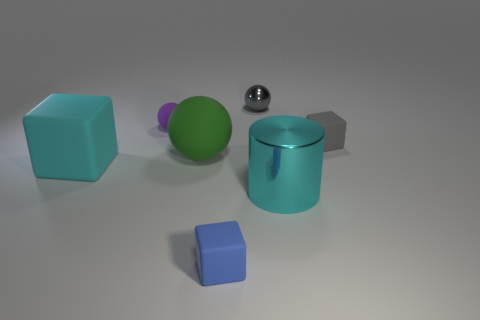What color is the other small metallic thing that is the same shape as the green thing?
Your response must be concise. Gray. Is the gray object to the right of the metal sphere made of the same material as the big cyan object that is to the left of the cyan metallic object?
Give a very brief answer. Yes. There is a big rubber block; is its color the same as the tiny block that is on the left side of the tiny gray ball?
Offer a terse response. No. What shape is the big object that is both on the right side of the cyan matte cube and in front of the green matte sphere?
Make the answer very short. Cylinder. What number of tiny purple spheres are there?
Provide a succinct answer. 1. What shape is the object that is the same color as the big cube?
Provide a succinct answer. Cylinder. There is another matte object that is the same shape as the green object; what is its size?
Provide a succinct answer. Small. Do the small matte thing on the right side of the gray shiny sphere and the big green rubber thing have the same shape?
Your response must be concise. No. What color is the block that is on the right side of the large cyan metallic object?
Offer a very short reply. Gray. How many other objects are there of the same size as the blue cube?
Your answer should be compact. 3. 